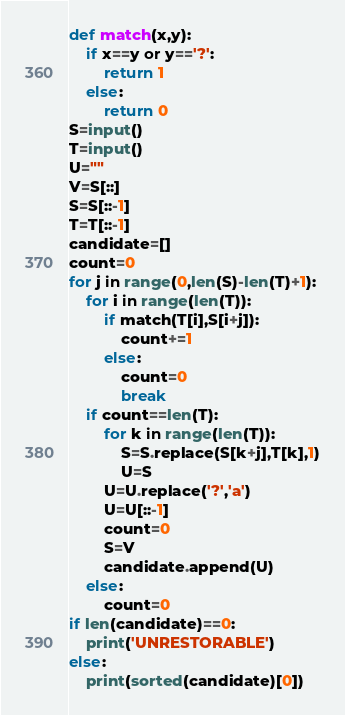Convert code to text. <code><loc_0><loc_0><loc_500><loc_500><_Python_>def match(x,y):
    if x==y or y=='?':
        return 1
    else:
        return 0
S=input()
T=input()
U=""
V=S[::]
S=S[::-1]
T=T[::-1]
candidate=[]
count=0
for j in range(0,len(S)-len(T)+1):
    for i in range(len(T)):
        if match(T[i],S[i+j]):
            count+=1
        else:
            count=0
            break
    if count==len(T):
        for k in range(len(T)):
            S=S.replace(S[k+j],T[k],1)
            U=S       
        U=U.replace('?','a')
        U=U[::-1]
        count=0
        S=V
        candidate.append(U)
    else:
        count=0
if len(candidate)==0:
    print('UNRESTORABLE')
else:
    print(sorted(candidate)[0])</code> 